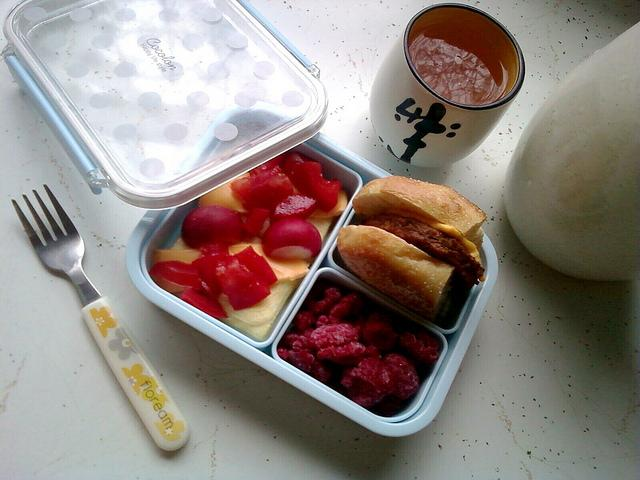What item resembles the item all the way to the left? fork 